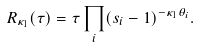Convert formula to latex. <formula><loc_0><loc_0><loc_500><loc_500>R _ { \kappa _ { 1 } } ( \tau ) = \tau \prod _ { i } ( s _ { i } - 1 ) ^ { - \kappa _ { 1 } \theta _ { i } } .</formula> 